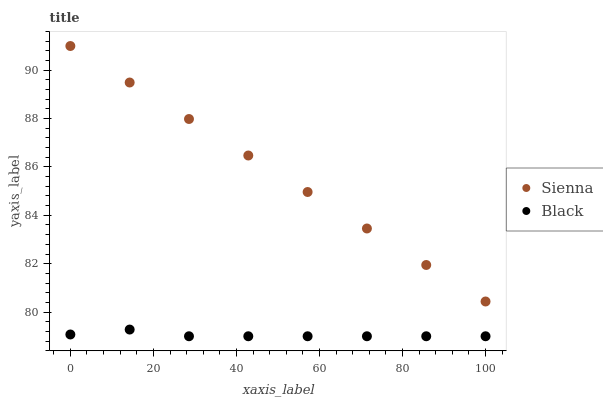Does Black have the minimum area under the curve?
Answer yes or no. Yes. Does Sienna have the maximum area under the curve?
Answer yes or no. Yes. Does Black have the maximum area under the curve?
Answer yes or no. No. Is Sienna the smoothest?
Answer yes or no. Yes. Is Black the roughest?
Answer yes or no. Yes. Is Black the smoothest?
Answer yes or no. No. Does Black have the lowest value?
Answer yes or no. Yes. Does Sienna have the highest value?
Answer yes or no. Yes. Does Black have the highest value?
Answer yes or no. No. Is Black less than Sienna?
Answer yes or no. Yes. Is Sienna greater than Black?
Answer yes or no. Yes. Does Black intersect Sienna?
Answer yes or no. No. 